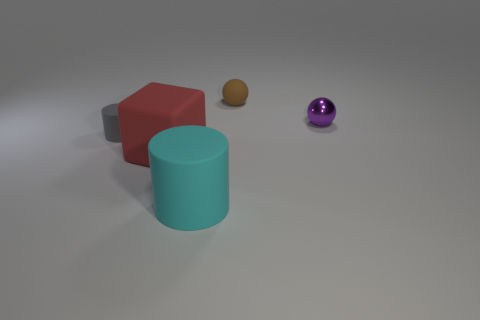Add 3 tiny purple metallic balls. How many objects exist? 8 Subtract all brown balls. How many balls are left? 1 Subtract all cubes. How many objects are left? 4 Subtract 0 cyan cubes. How many objects are left? 5 Subtract all gray balls. Subtract all yellow cylinders. How many balls are left? 2 Subtract all small purple metallic objects. Subtract all large yellow matte spheres. How many objects are left? 4 Add 4 tiny gray things. How many tiny gray things are left? 5 Add 4 brown rubber objects. How many brown rubber objects exist? 5 